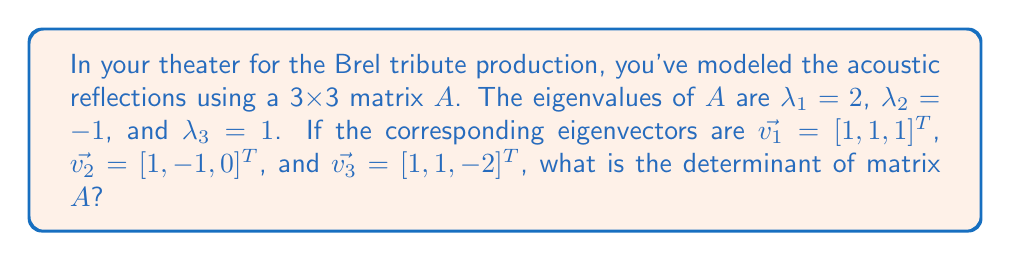Can you solve this math problem? Let's approach this step-by-step:

1) First, recall that for a 3x3 matrix, the determinant is equal to the product of its eigenvalues:

   $\det(A) = \lambda_1 \cdot \lambda_2 \cdot \lambda_3$

2) We're given the eigenvalues:
   $\lambda_1 = 2$
   $\lambda_2 = -1$
   $\lambda_3 = 1$

3) Let's multiply these values:

   $\det(A) = 2 \cdot (-1) \cdot 1$

4) Simplifying:

   $\det(A) = -2$

Note: The eigenvectors provided in the question are not needed to solve this problem. They would be useful for other calculations, such as diagonalizing the matrix or analyzing specific acoustic modes in the theater.
Answer: $-2$ 